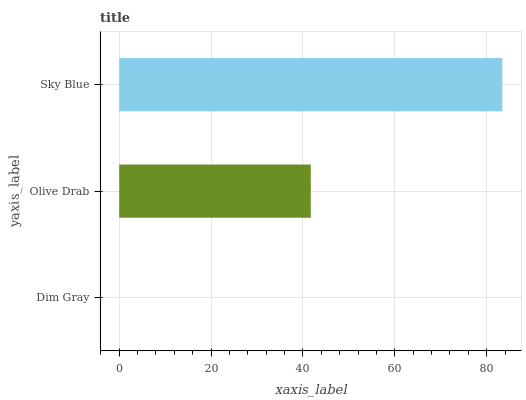Is Dim Gray the minimum?
Answer yes or no. Yes. Is Sky Blue the maximum?
Answer yes or no. Yes. Is Olive Drab the minimum?
Answer yes or no. No. Is Olive Drab the maximum?
Answer yes or no. No. Is Olive Drab greater than Dim Gray?
Answer yes or no. Yes. Is Dim Gray less than Olive Drab?
Answer yes or no. Yes. Is Dim Gray greater than Olive Drab?
Answer yes or no. No. Is Olive Drab less than Dim Gray?
Answer yes or no. No. Is Olive Drab the high median?
Answer yes or no. Yes. Is Olive Drab the low median?
Answer yes or no. Yes. Is Sky Blue the high median?
Answer yes or no. No. Is Dim Gray the low median?
Answer yes or no. No. 